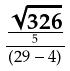<formula> <loc_0><loc_0><loc_500><loc_500>\frac { \frac { \sqrt { 3 2 6 } } { 5 } } { ( 2 9 - 4 ) }</formula> 